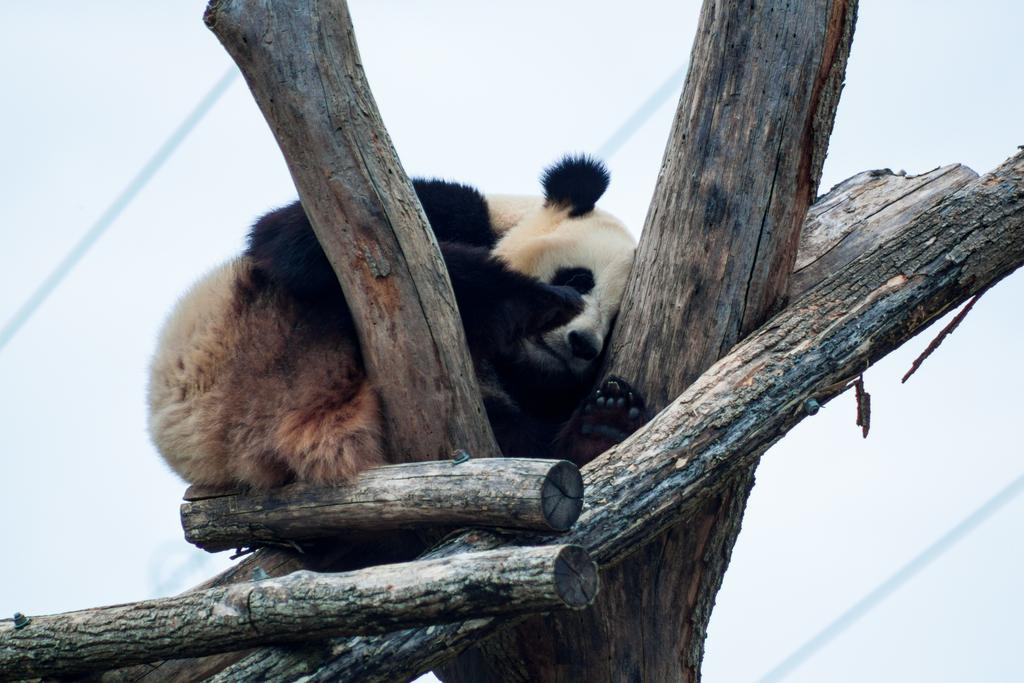What animal is featured in the image? There is a panda in the image. What is the panda doing in the image? The panda is sitting on a tree. What else can be seen near the tree in the image? There are logs of wood beside the tree in the image. What type of treatment is the panda receiving in the image? There is no indication in the image that the panda is receiving any treatment. 